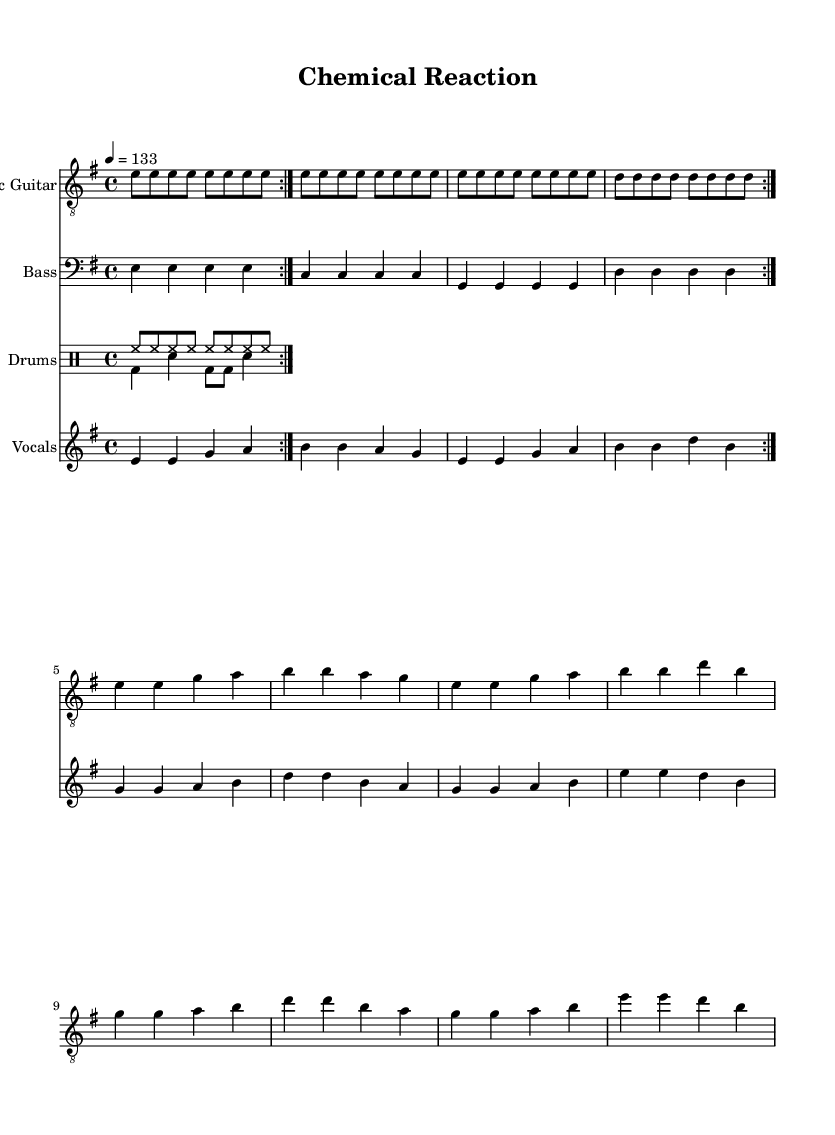What is the key signature of this music? The key signature is indicated by the 'key' command at the beginning of the score, which shows that the piece is in E minor, signifying one sharp (F#).
Answer: E minor What is the time signature of this music? The time signature is represented by the 'time' command at the beginning, which states that it is in 4/4 time, meaning there are four beats in each measure.
Answer: 4/4 What is the tempo of the piece? The tempo is given in the 'tempo' command, which shows a speed of 133 beats per minute (4 = 133).
Answer: 133 How many measures are in the electric guitar part? By counting the repeats and measures, there are 16 measures total in the electric guitar part, including the repeats.
Answer: 16 Which instrument has the highest pitch in the arrangement? The highest pitch would be in the electric guitar staff, as it typically plays in a higher register compared to the bass and drums.
Answer: Electric Guitar How does the vocal melody correspond with the lyrics? The vocal melody is structured to align with the lyrics directly above it, with the syllables spaced out to match the notes in a one-to-one relationship as per the 'lyric' command.
Answer: One-to-one alignment What is the primary theme of the song based on the lyrics? The lyrics focus on laboratory work, chemical reactions, and scientific dedication, emphasizing the commitment to research and development.
Answer: Laboratory dedication 